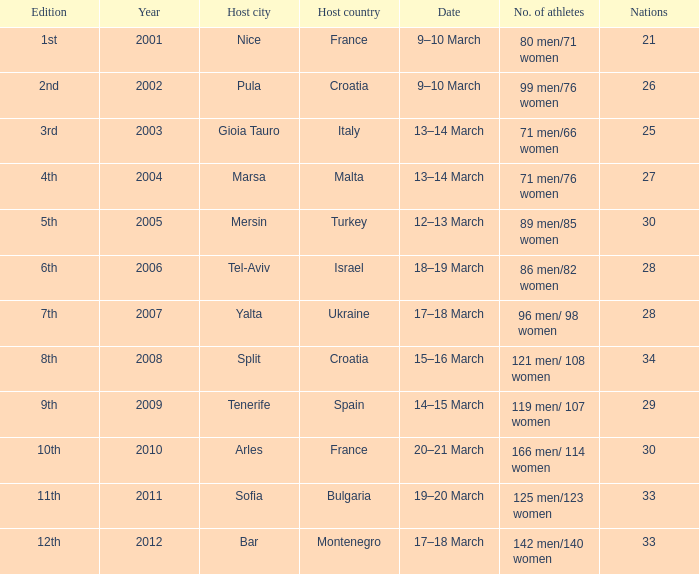What was the most recent year? 2012.0. 